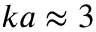<formula> <loc_0><loc_0><loc_500><loc_500>k a \approx 3</formula> 